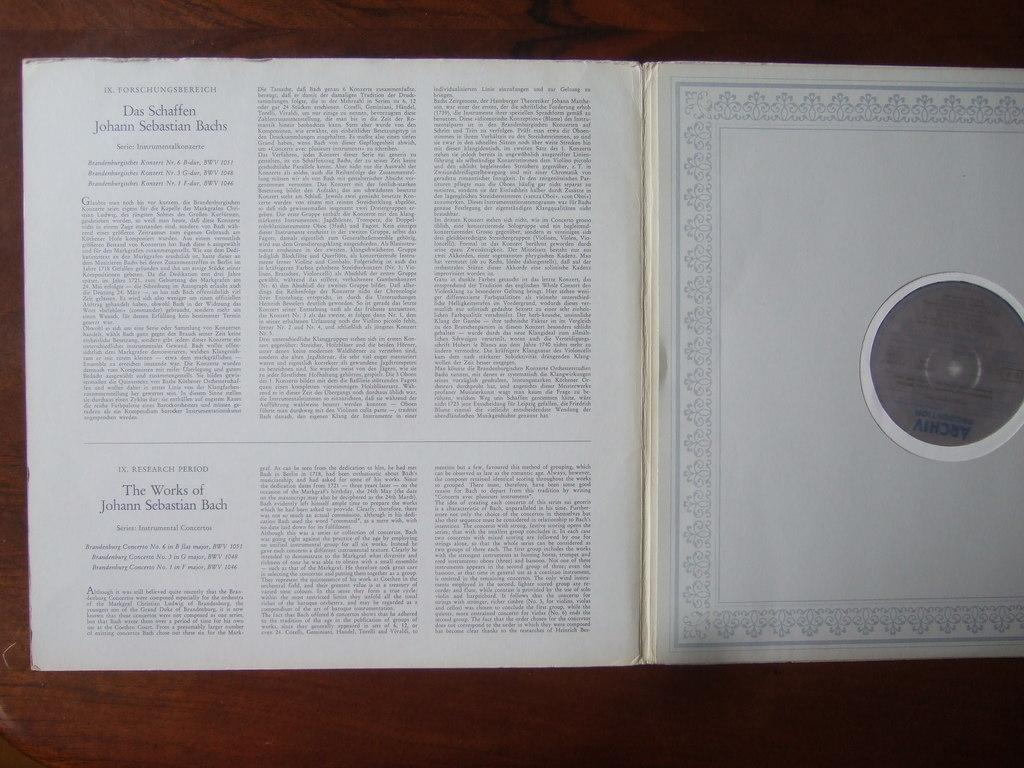<image>
Offer a succinct explanation of the picture presented. A book is opened to section 9, Forschungsbereich. 